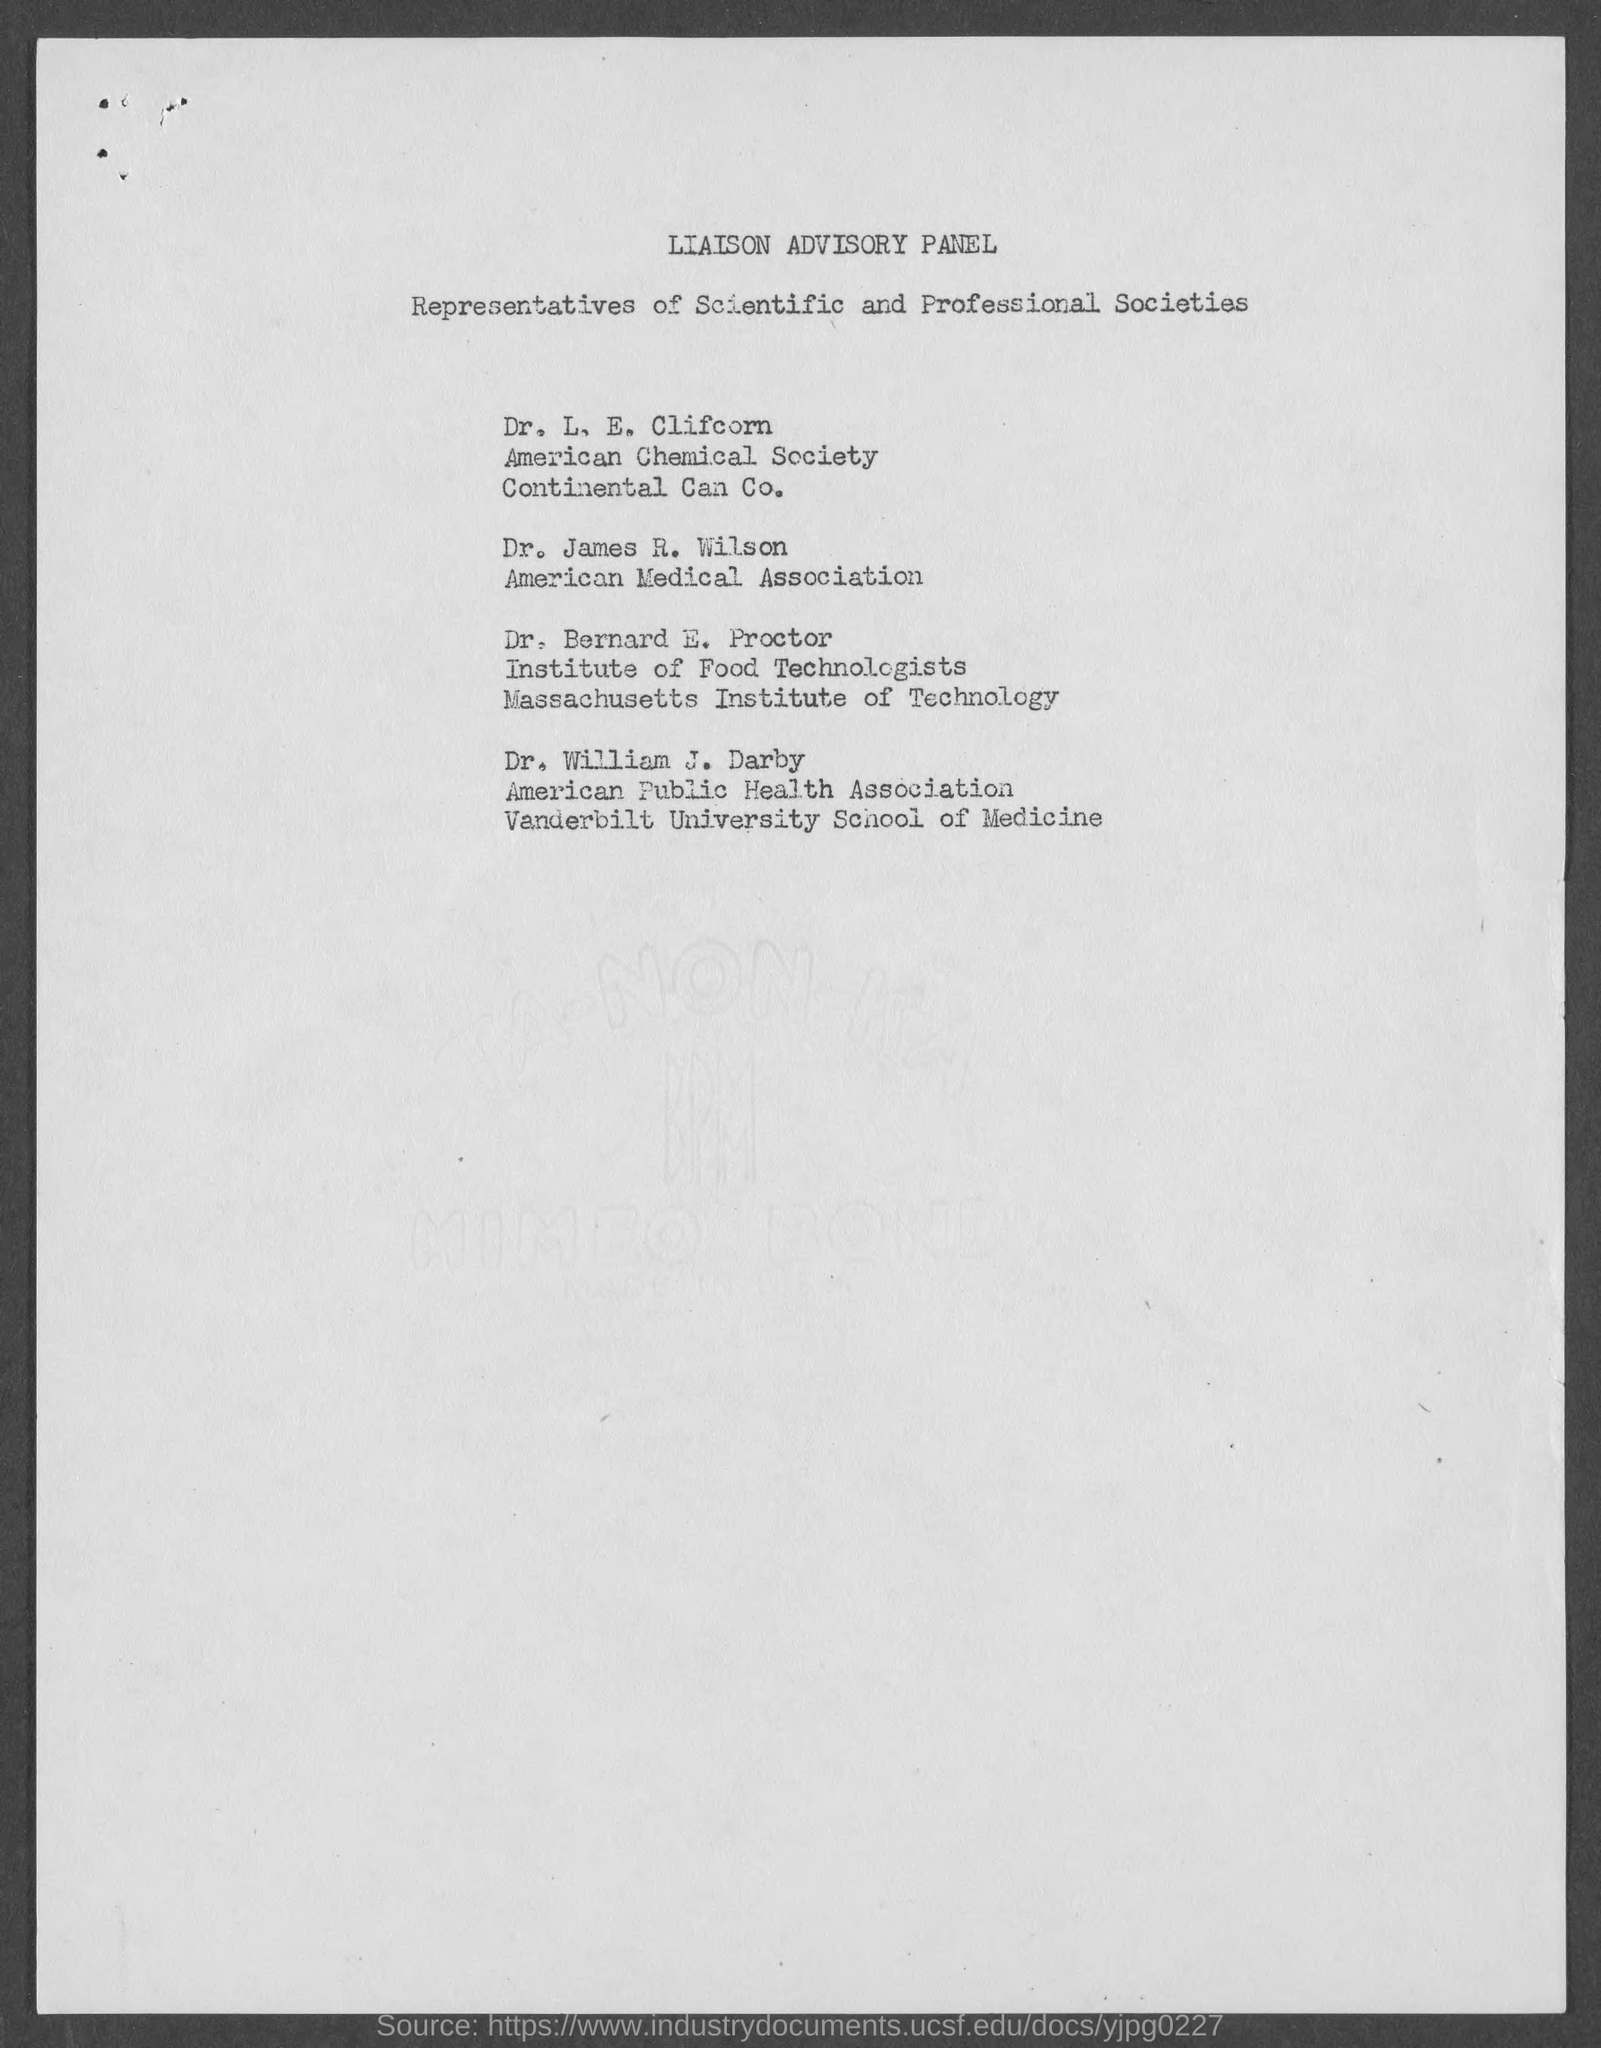Who are the persons listed in the document?
Your response must be concise. Representatives of Scientific and Professional Societies. Who is from american medical association?
Give a very brief answer. Dr. James R. Wilson. 